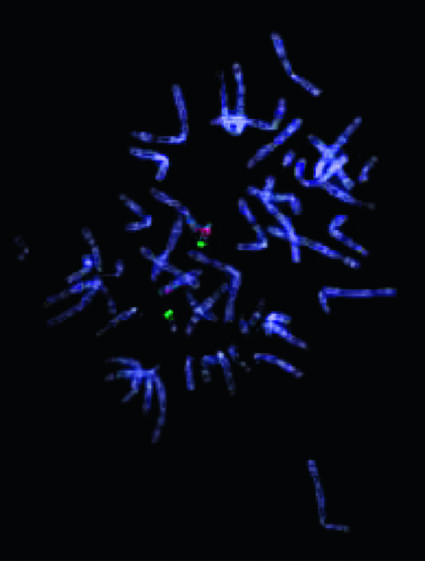how many 22q13 signals are there?
Answer the question using a single word or phrase. Two 